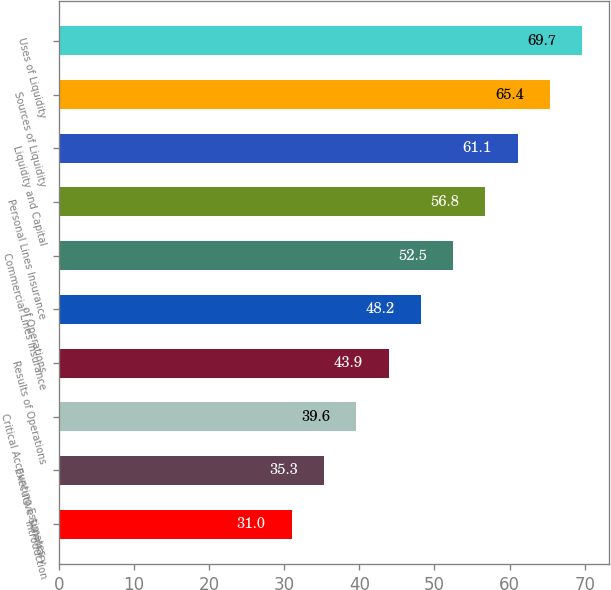<chart> <loc_0><loc_0><loc_500><loc_500><bar_chart><fcel>Introduction<fcel>Executive Summary<fcel>Critical Accounting Estimates<fcel>Results of Operations<fcel>of Operations<fcel>Commercial Lines Insurance<fcel>Personal Lines Insurance<fcel>Liquidity and Capital<fcel>Sources of Liquidity<fcel>Uses of Liquidity<nl><fcel>31<fcel>35.3<fcel>39.6<fcel>43.9<fcel>48.2<fcel>52.5<fcel>56.8<fcel>61.1<fcel>65.4<fcel>69.7<nl></chart> 